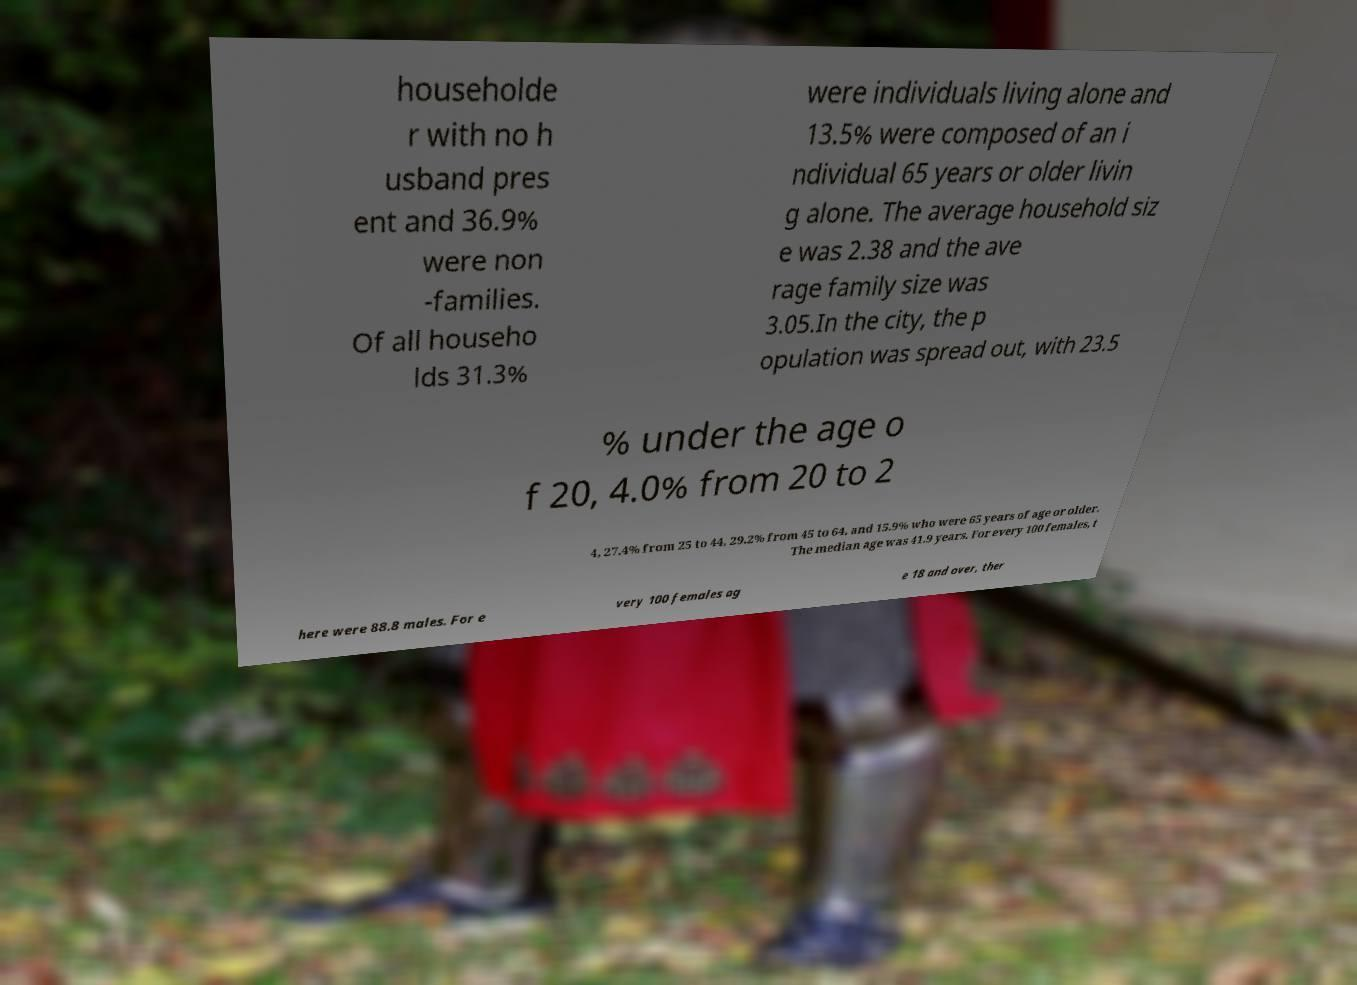I need the written content from this picture converted into text. Can you do that? householde r with no h usband pres ent and 36.9% were non -families. Of all househo lds 31.3% were individuals living alone and 13.5% were composed of an i ndividual 65 years or older livin g alone. The average household siz e was 2.38 and the ave rage family size was 3.05.In the city, the p opulation was spread out, with 23.5 % under the age o f 20, 4.0% from 20 to 2 4, 27.4% from 25 to 44, 29.2% from 45 to 64, and 15.9% who were 65 years of age or older. The median age was 41.9 years. For every 100 females, t here were 88.8 males. For e very 100 females ag e 18 and over, ther 